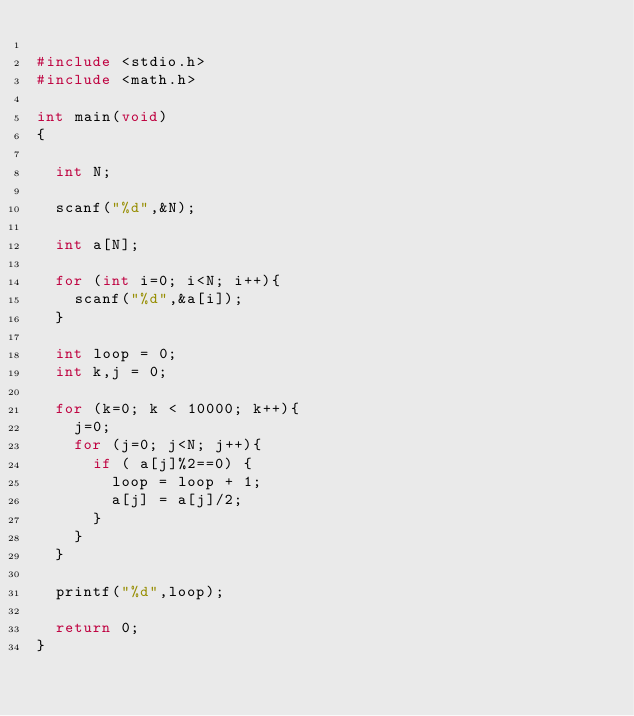Convert code to text. <code><loc_0><loc_0><loc_500><loc_500><_C_>
#include <stdio.h>
#include <math.h>

int main(void)
{

	int N;
	
	scanf("%d",&N);
	
	int a[N];

	for (int i=0; i<N; i++){
		scanf("%d",&a[i]);
	}

	int loop = 0;
	int k,j = 0;

	for (k=0; k < 10000; k++){
		j=0;
		for (j=0; j<N; j++){
			if ( a[j]%2==0) {
				loop = loop + 1;
				a[j] = a[j]/2;
			}
		}
	}

	printf("%d",loop);

	return 0;
}
</code> 